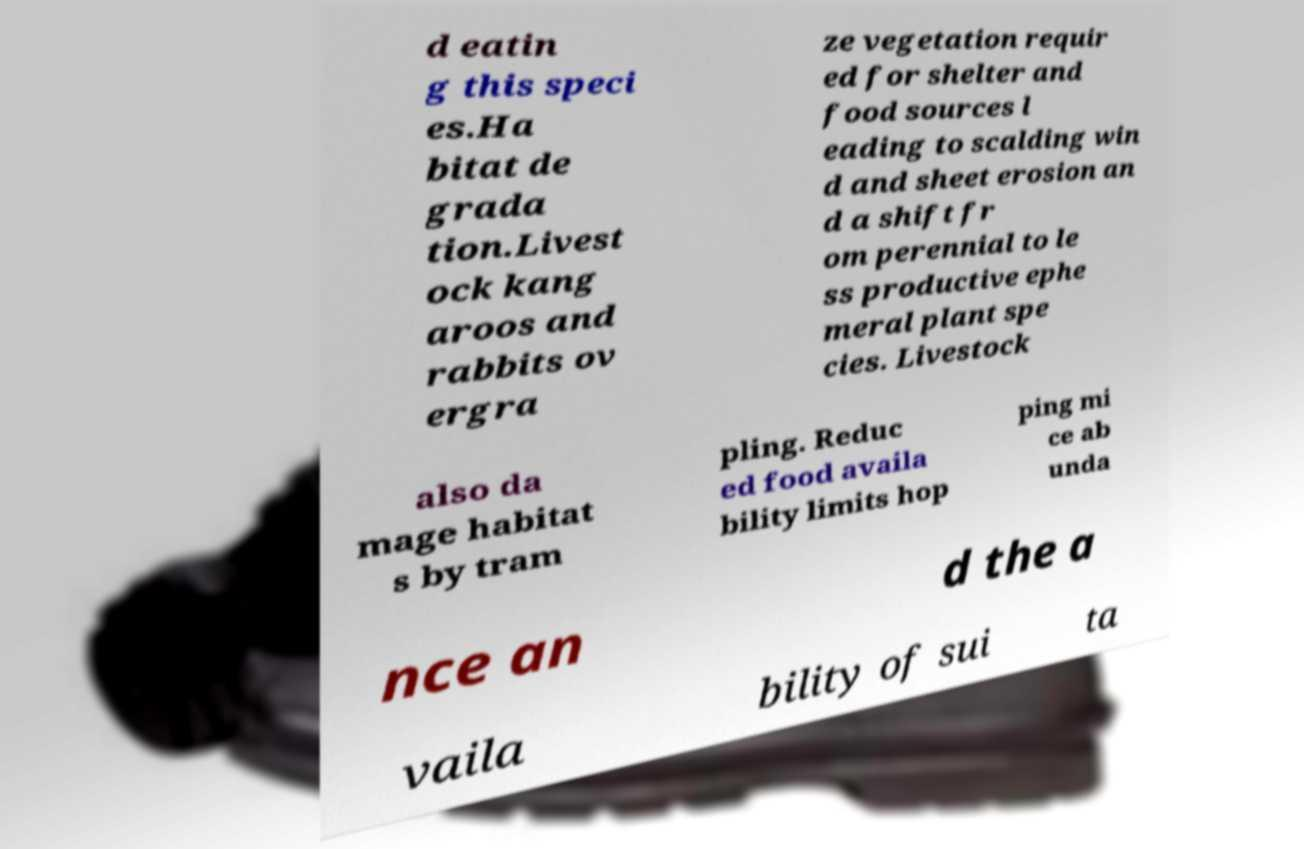Please read and relay the text visible in this image. What does it say? d eatin g this speci es.Ha bitat de grada tion.Livest ock kang aroos and rabbits ov ergra ze vegetation requir ed for shelter and food sources l eading to scalding win d and sheet erosion an d a shift fr om perennial to le ss productive ephe meral plant spe cies. Livestock also da mage habitat s by tram pling. Reduc ed food availa bility limits hop ping mi ce ab unda nce an d the a vaila bility of sui ta 